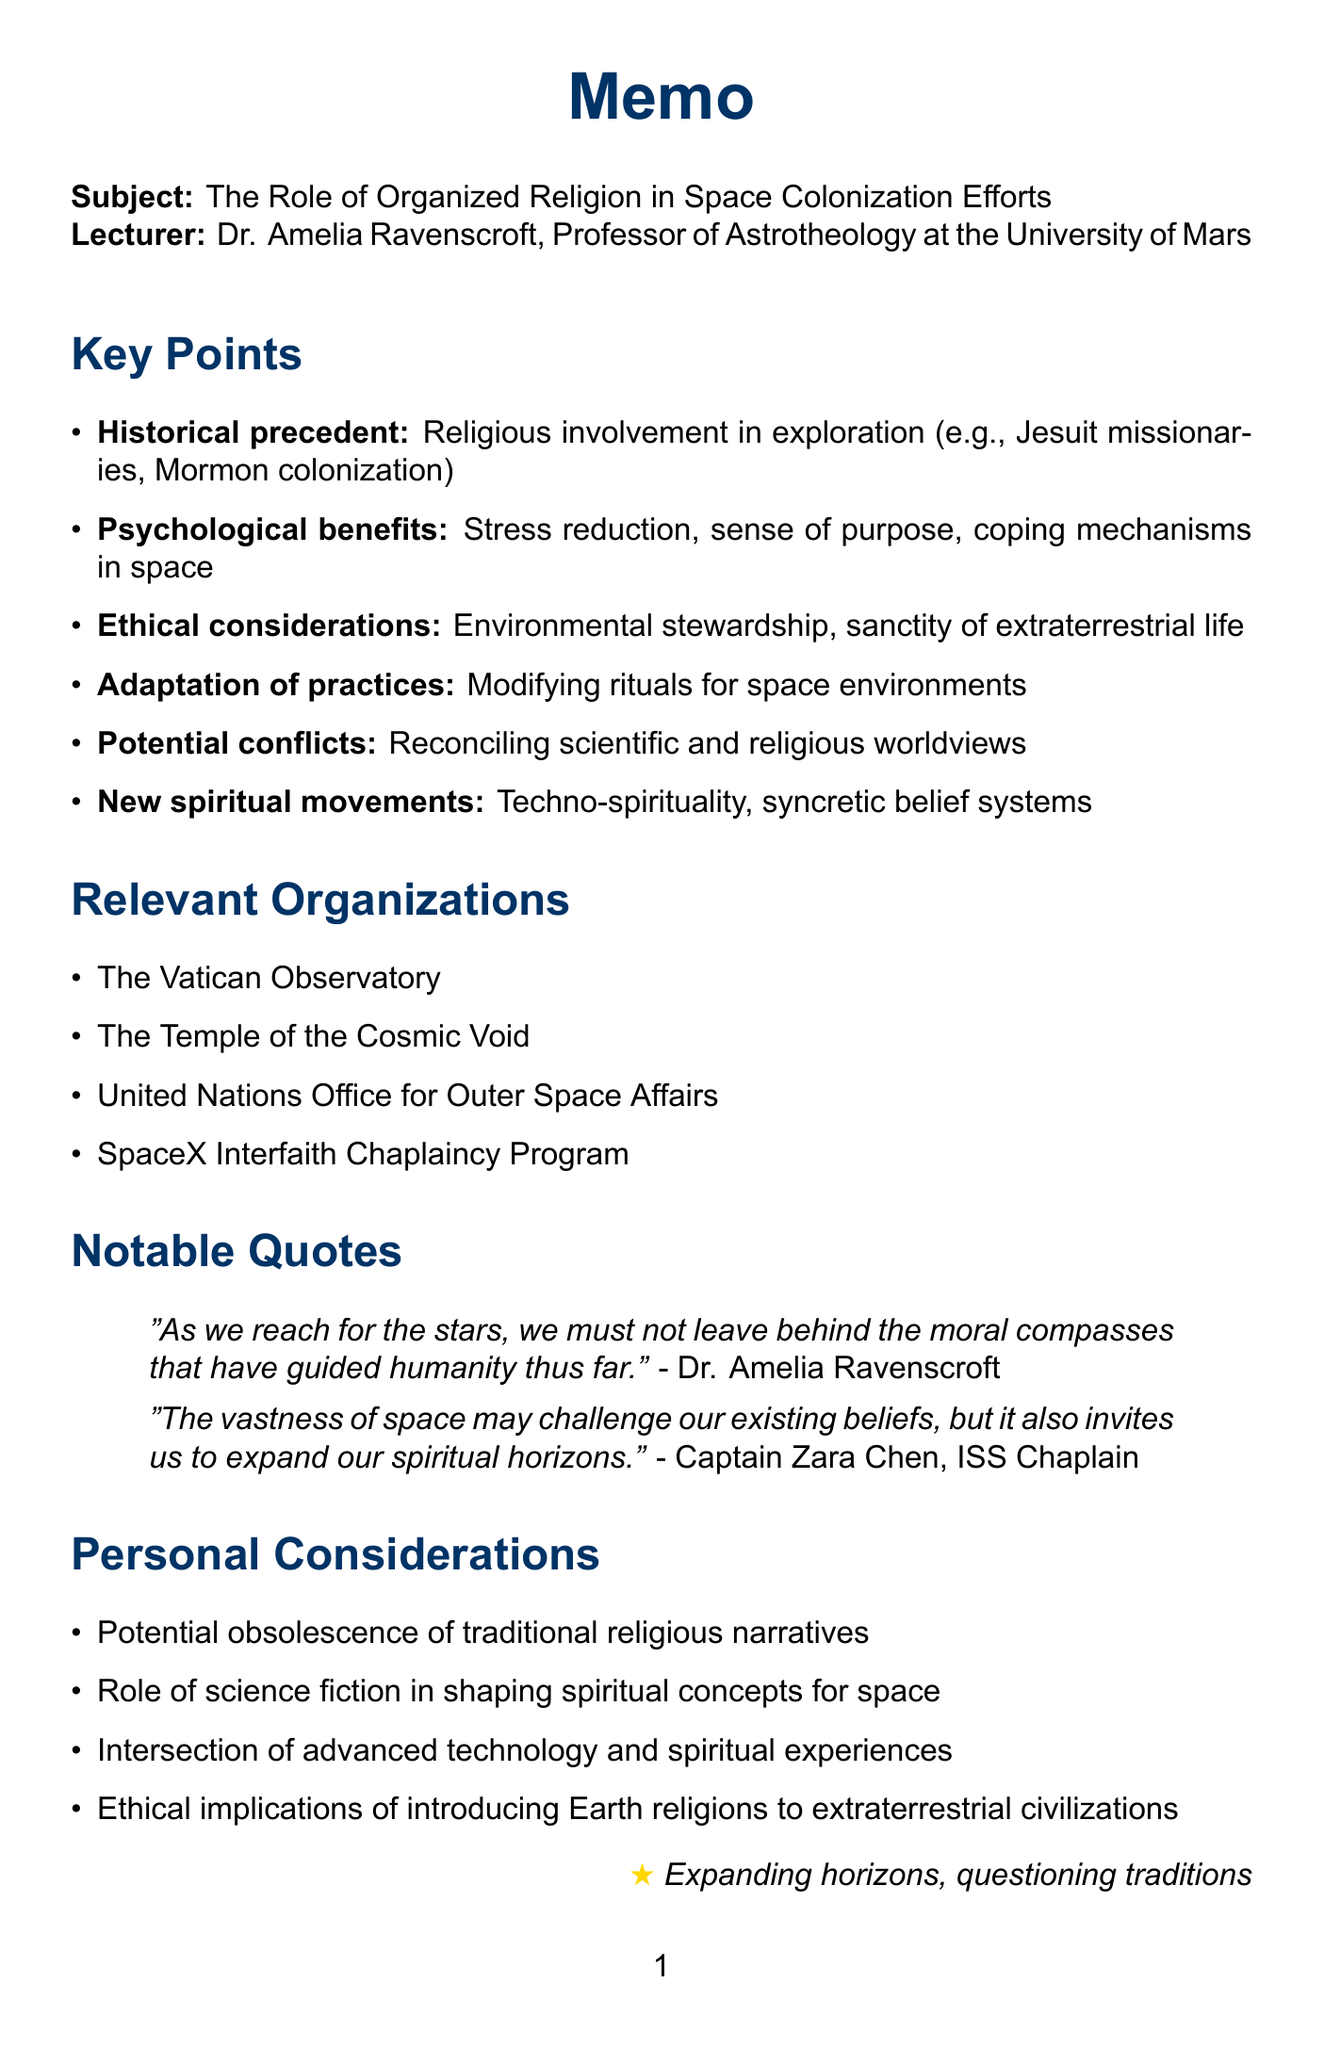What is the title of the lecture? The title of the lecture is explicitly stated in the document's subject.
Answer: The Role of Organized Religion in Space Colonization Efforts Who is the lecturer? The lecturer's name and title are provided under the subject of the document.
Answer: Dr. Amelia Ravenscroft What is one historical precedent of religious involvement in exploration mentioned in the document? The document lists examples of religious involvement in exploration under key points, one of which is identified.
Answer: Jesuit missionaries in the Age of Discovery What are two ethical considerations in terraforming and colonization? The document outlines ethical considerations and lists multiple aspects under key points.
Answer: Environmental stewardship, sanctity of extraterrestrial life What does the document say about potential conflicts between scientific and religious worldviews? The document discusses potential conflicts and highlights tensions present within the key points section.
Answer: Reconciling creation myths with astrophysical evidence Name one relevant organization mentioned in the document. The document lists organizations that are relevant to the topic discussed.
Answer: The Vatican Observatory What is the rise of new spiritual movements in space colonies referred to in the document? The document mentions new spiritual movements as part of key points, highlighting this emerging trend.
Answer: Techno-spirituality and AI worship How is the role of science fiction literature characterized in the context of spiritual concepts for space colonization? The personal considerations section discusses the influence of science fiction literature on spirituality in space colonization.
Answer: Shaping spiritual concepts for space What is one notable quote from Dr. Amelia Ravenscroft? The document includes notable quotes from speakers relevant to the lecture.
Answer: "As we reach for the stars, we must not leave behind the moral compasses that have guided humanity thus far." 